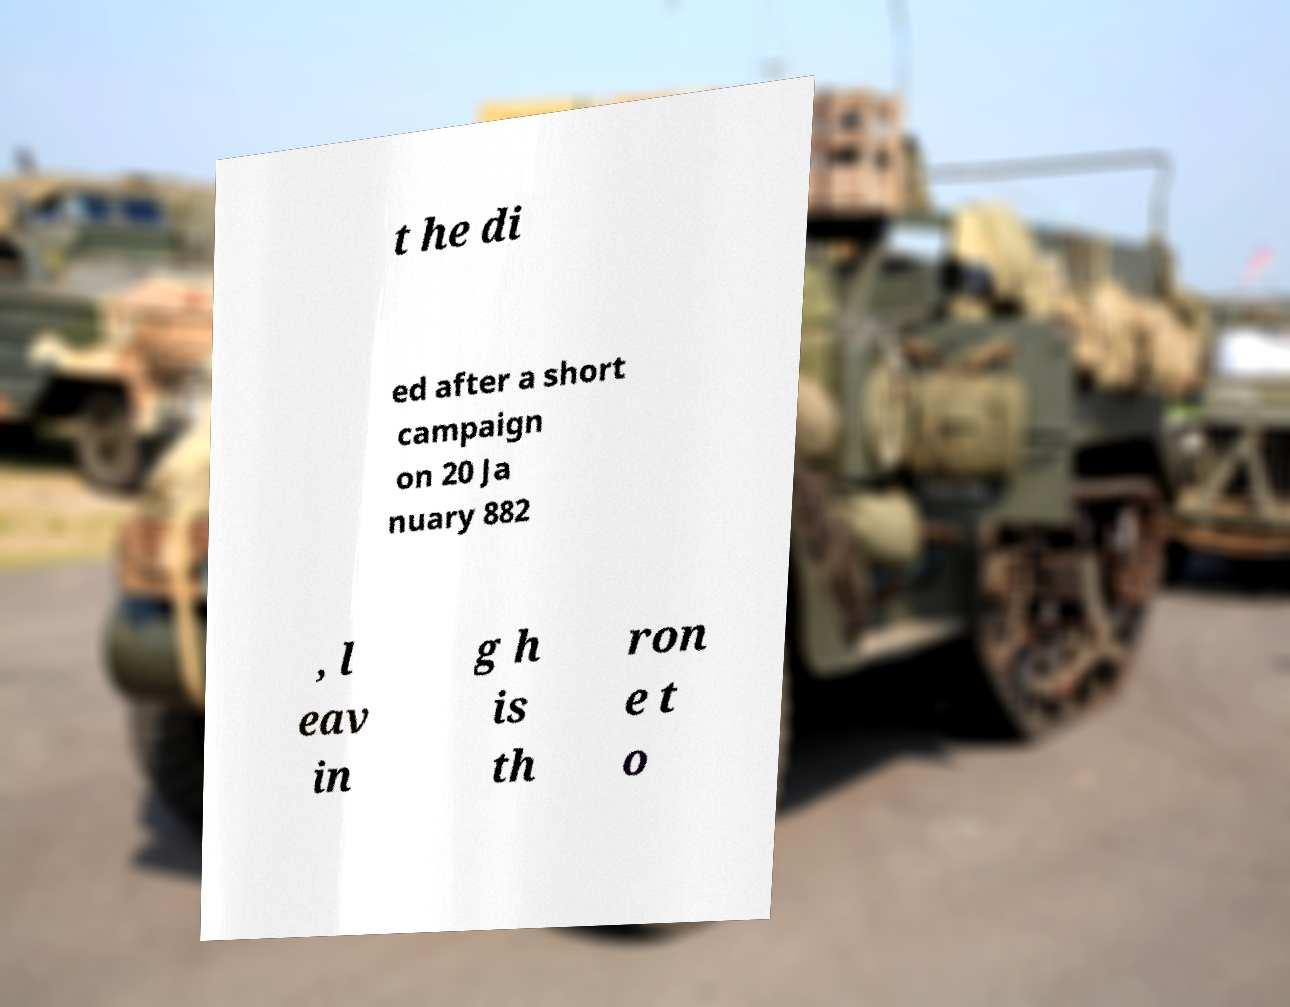Could you assist in decoding the text presented in this image and type it out clearly? t he di ed after a short campaign on 20 Ja nuary 882 , l eav in g h is th ron e t o 